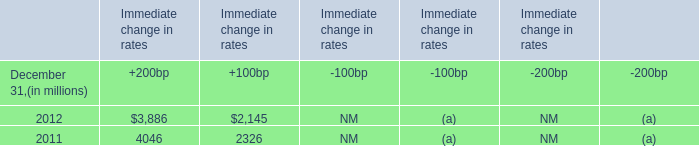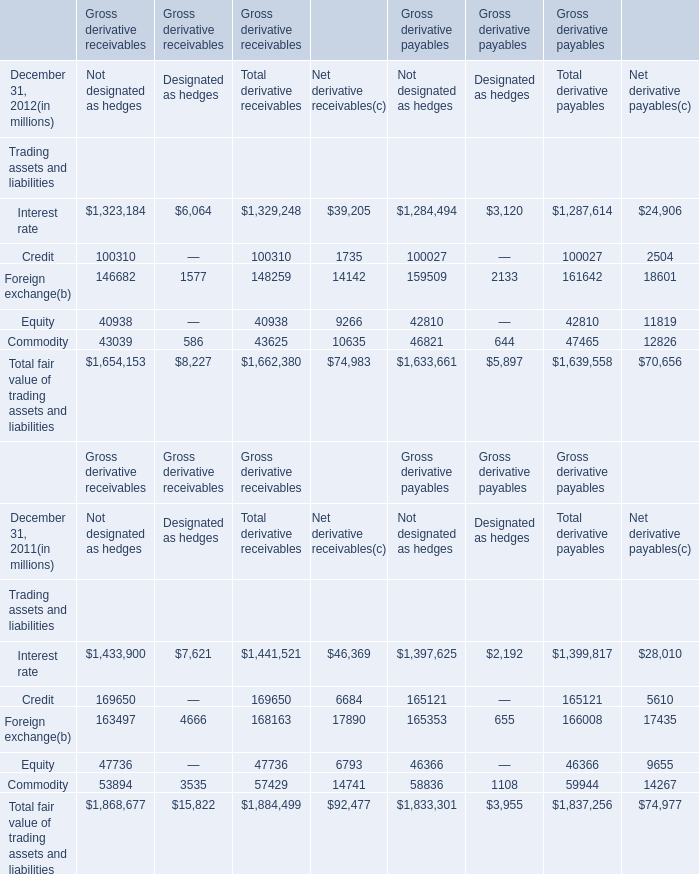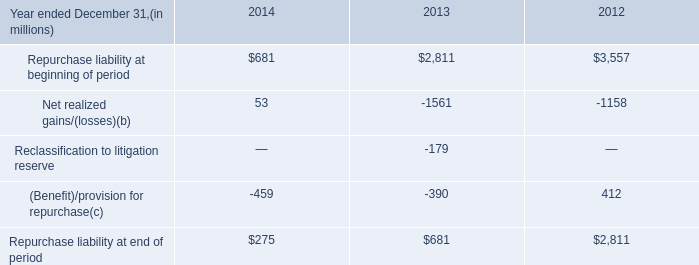based on the summary of changes in mortgage repurchase liability what was the percent of the change in the repurchase liability 
Computations: ((275 - 681) / 681)
Answer: -0.59618. 